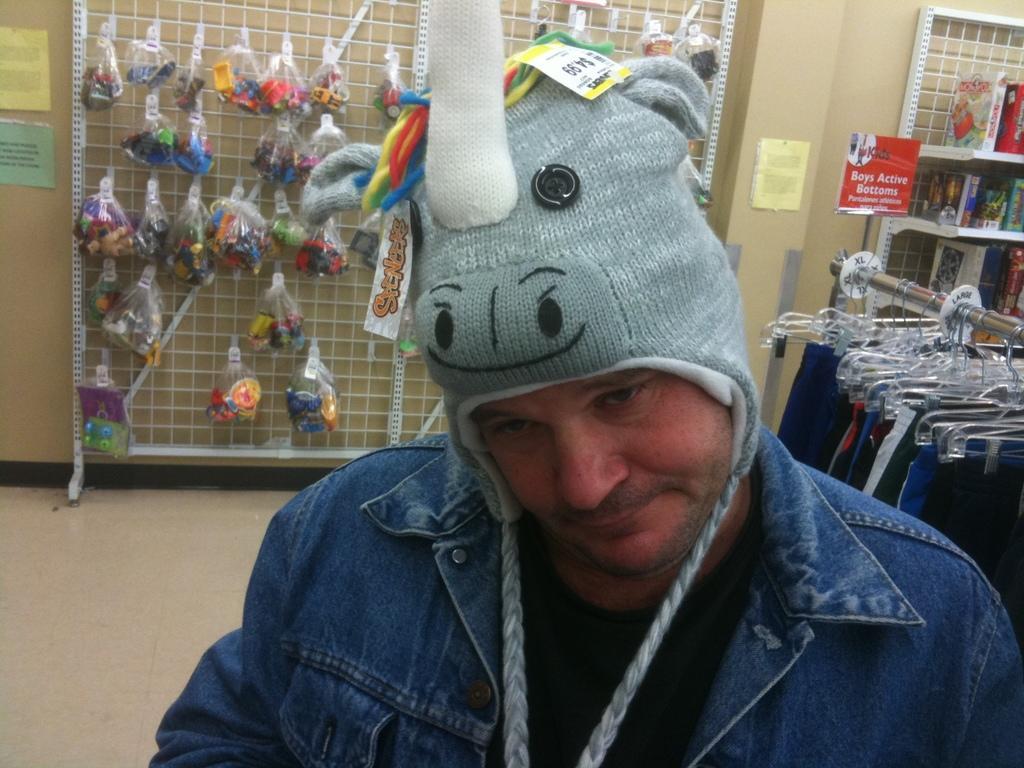Please provide a concise description of this image. In this image we can see a man wearing a cap. In the background there is a board and we can see things placed on the board. On the right there are clothes placed on the hanger. There is a shelf and there are books placed in the shelf. 